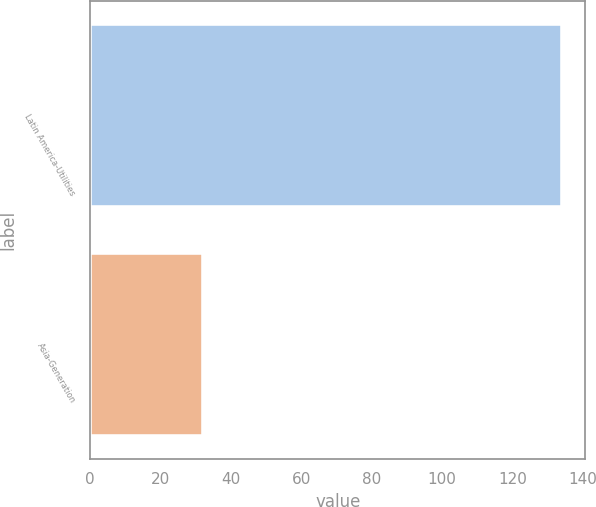Convert chart to OTSL. <chart><loc_0><loc_0><loc_500><loc_500><bar_chart><fcel>Latin America-Utilities<fcel>Asia-Generation<nl><fcel>134<fcel>32<nl></chart> 